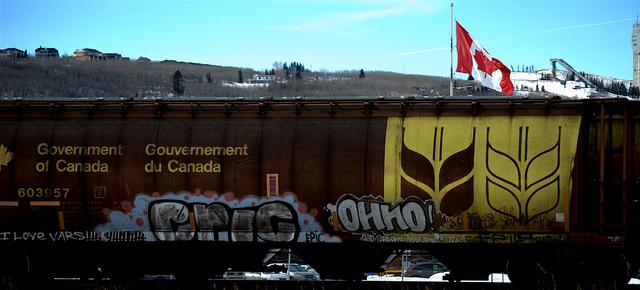Is there graffiti on the train?
Concise answer only. Yes. What country's flag is in this photo?
Write a very short answer. Canada. Is the graffiti done ok?
Concise answer only. Yes. Is this a bar?
Be succinct. No. 